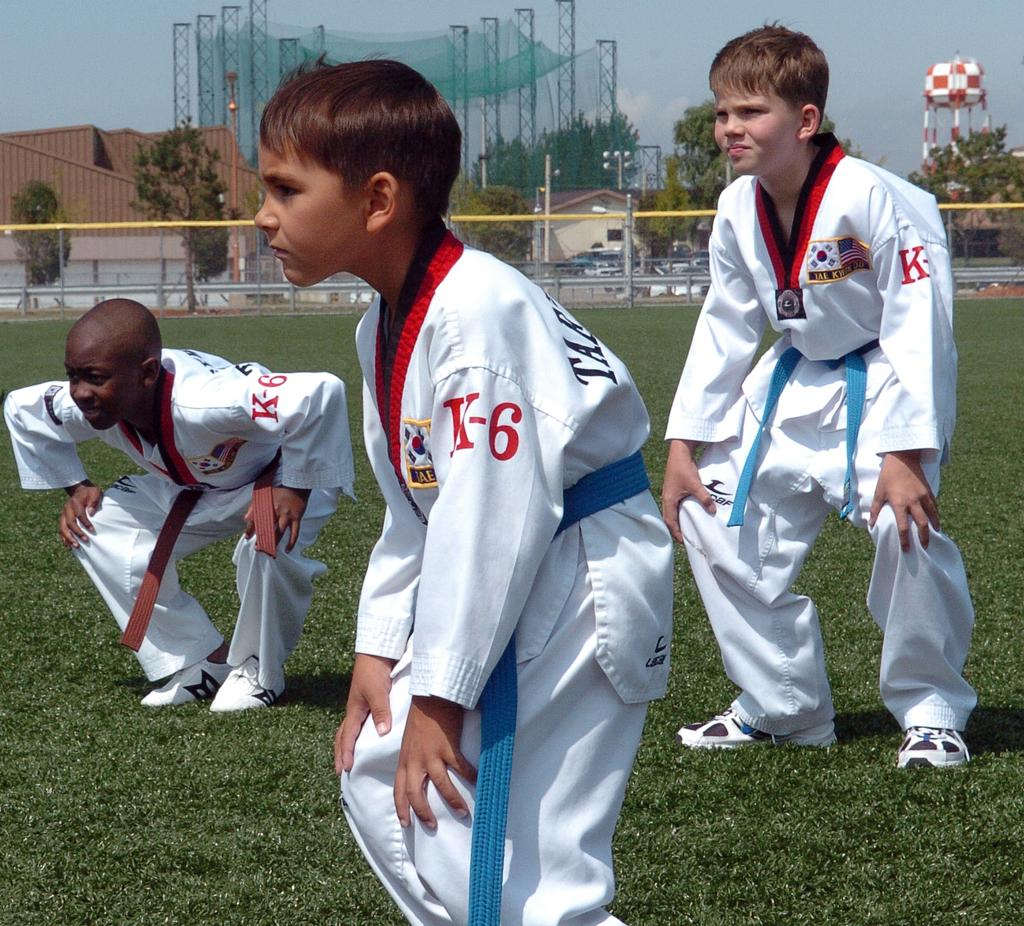<image>
Describe the image concisely. Some young boys in martial arts uniforms practice on a field, K-6 on the arm of their uniforms. 